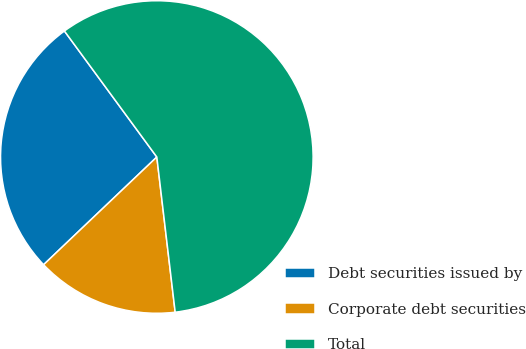Convert chart to OTSL. <chart><loc_0><loc_0><loc_500><loc_500><pie_chart><fcel>Debt securities issued by<fcel>Corporate debt securities<fcel>Total<nl><fcel>27.03%<fcel>14.77%<fcel>58.19%<nl></chart> 